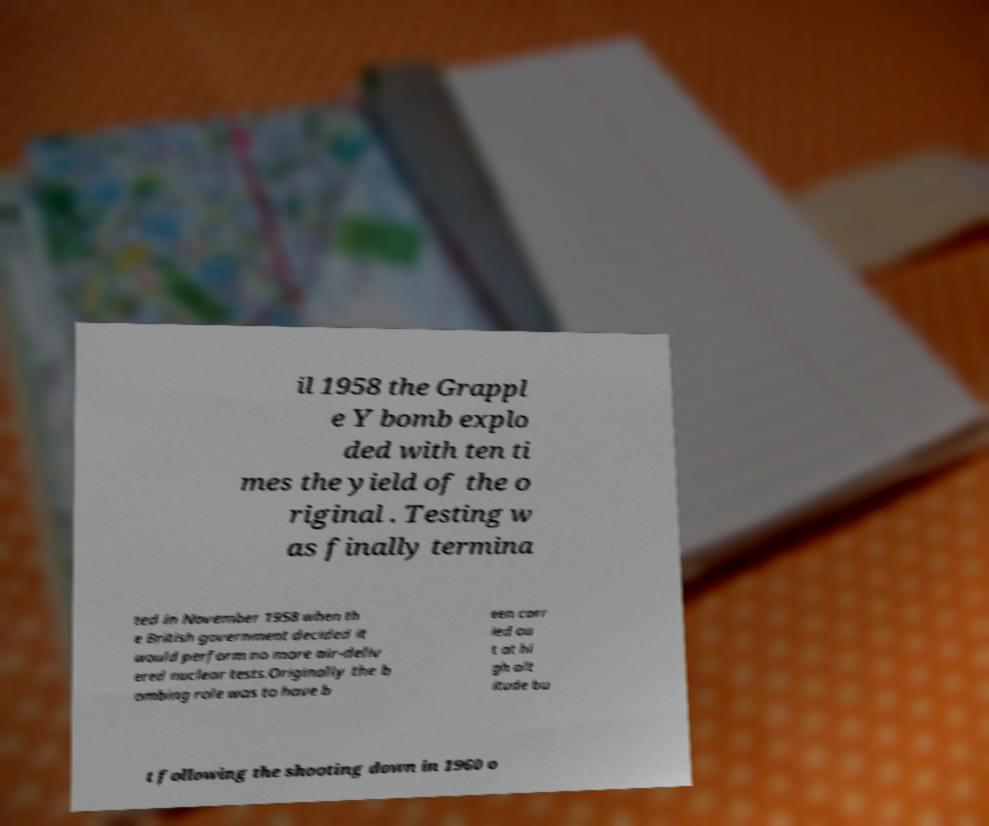Please identify and transcribe the text found in this image. il 1958 the Grappl e Y bomb explo ded with ten ti mes the yield of the o riginal . Testing w as finally termina ted in November 1958 when th e British government decided it would perform no more air-deliv ered nuclear tests.Originally the b ombing role was to have b een carr ied ou t at hi gh alt itude bu t following the shooting down in 1960 o 